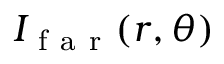<formula> <loc_0><loc_0><loc_500><loc_500>I _ { f a r } ( r , \theta )</formula> 